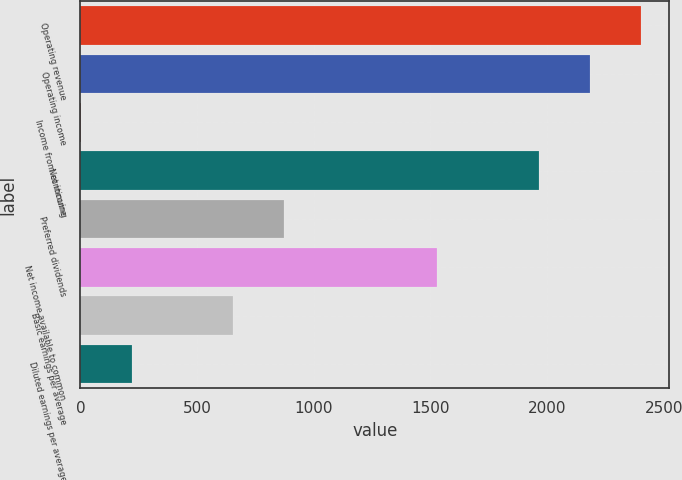<chart> <loc_0><loc_0><loc_500><loc_500><bar_chart><fcel>Operating revenue<fcel>Operating income<fcel>Income from continuing<fcel>Net income<fcel>Preferred dividends<fcel>Net income available to common<fcel>Basic earnings per average<fcel>Diluted earnings per average<nl><fcel>2402.4<fcel>2184.04<fcel>0.44<fcel>1965.68<fcel>873.88<fcel>1528.96<fcel>655.52<fcel>218.8<nl></chart> 